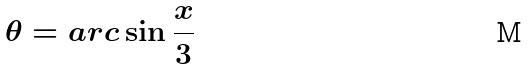Convert formula to latex. <formula><loc_0><loc_0><loc_500><loc_500>\theta = a r c \sin \frac { x } { 3 }</formula> 